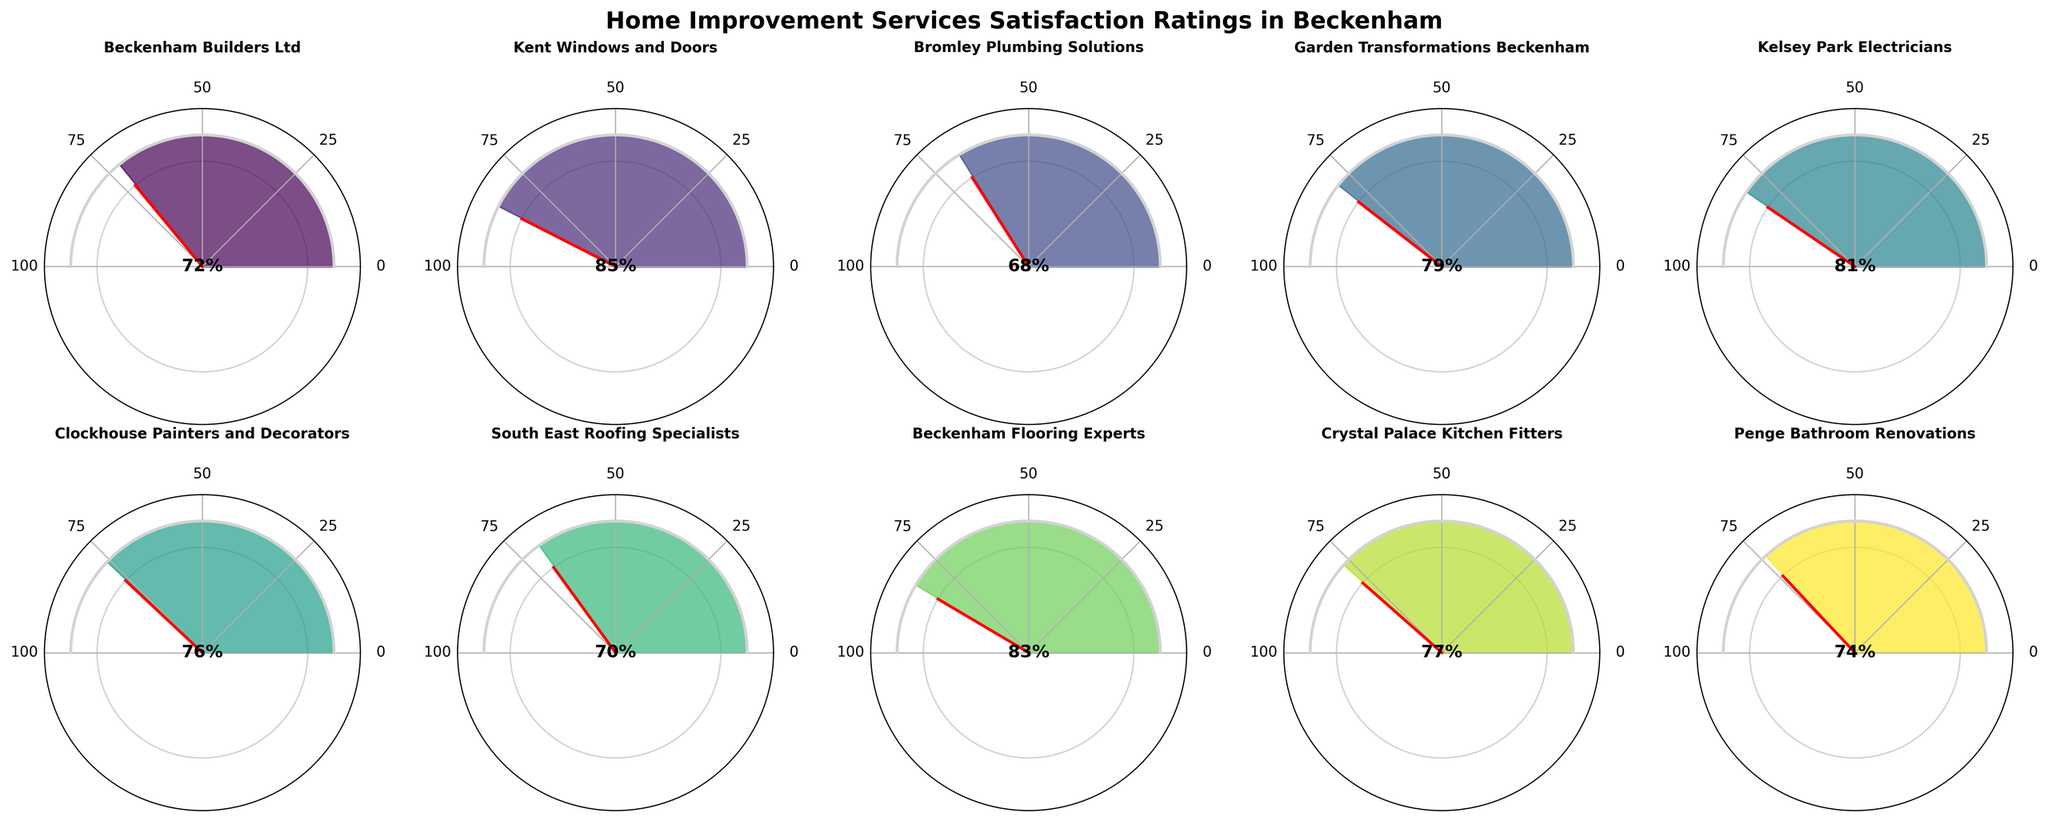Which service has the highest satisfaction rating? By looking at all the gauge charts in the figure, the service with the needle closest to 100% is Kent Windows and Doors.
Answer: Kent Windows and Doors Which service has the lowest satisfaction rating? By examining the gauge charts, Bromley Plumbing Solutions has the needle closest to 0%, indicating the lowest satisfaction rating.
Answer: Bromley Plumbing Solutions How many services have a satisfaction rating greater than 80%? Count the number of gauge charts where the needle is pointing above the 80% mark. Those services are Kent Windows and Doors, Kelsey Park Electricians, and Beckenham Flooring Experts.
Answer: 3 What's the average satisfaction rating for all services? Add up all the satisfaction ratings: 72 + 85 + 68 + 79 + 81 + 76 + 70 + 83 + 77 + 74 = 765. Divide by the number of services: 765 / 10 = 76.5
Answer: 76.5 Which services have a satisfaction rating between 70% and 80%? Identify the services with their needle between 70% and 80%. These are Beckenham Builders Ltd, Garden Transformations Beckenham, Clockhouse Painters and Decorators, Crystal Palace Kitchen Fitters, and Penge Bathroom Renovations.
Answer: Beckenham Builders Ltd, Garden Transformations Beckenham, Clockhouse Painters and Decorators, Crystal Palace Kitchen Fitters, Penge Bathroom Renovations How many services have a higher satisfaction rating than Clockhouse Painters and Decorators? Count the gauge charts where the needles point higher than 76%, the rating for Clockhouse Painters and Decorators. They are Kent Windows and Doors, Kelsey Park Electricians, Beckenham Flooring Experts, and Crystal Palace Kitchen Fitters.
Answer: 4 What is the median satisfaction rating for the services? List all ratings in ascending order: 68, 70, 72, 74, 76, 77, 79, 81, 83, 85. The median is the average of the fifth and sixth values: (76 + 77) / 2 = 76.5
Answer: 76.5 What is the total range of the satisfaction ratings? Subtract the lowest satisfaction rating from the highest: 85 (Kent Windows and Doors) - 68 (Bromley Plumbing Solutions) = 17
Answer: 17 How many services have a satisfaction rating between 60% and 90%? Count the number of gauge charts where the needles point between 60% and 90%. All services fall within this range.
Answer: 10 Which service is closest to the median satisfaction rating? The median rating is 76.5. Clockhouse Painters and Decorators have a rating of 76%, which is closest to the median.
Answer: Clockhouse Painters and Decorators 